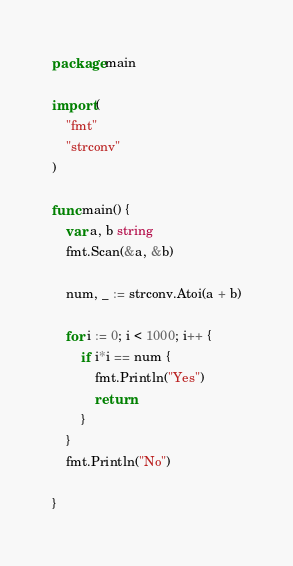Convert code to text. <code><loc_0><loc_0><loc_500><loc_500><_Go_>package main

import (
	"fmt"
	"strconv"
)

func main() {
	var a, b string
	fmt.Scan(&a, &b)

	num, _ := strconv.Atoi(a + b)

	for i := 0; i < 1000; i++ {
		if i*i == num {
			fmt.Println("Yes")
			return
		}
	}
	fmt.Println("No")

}
</code> 